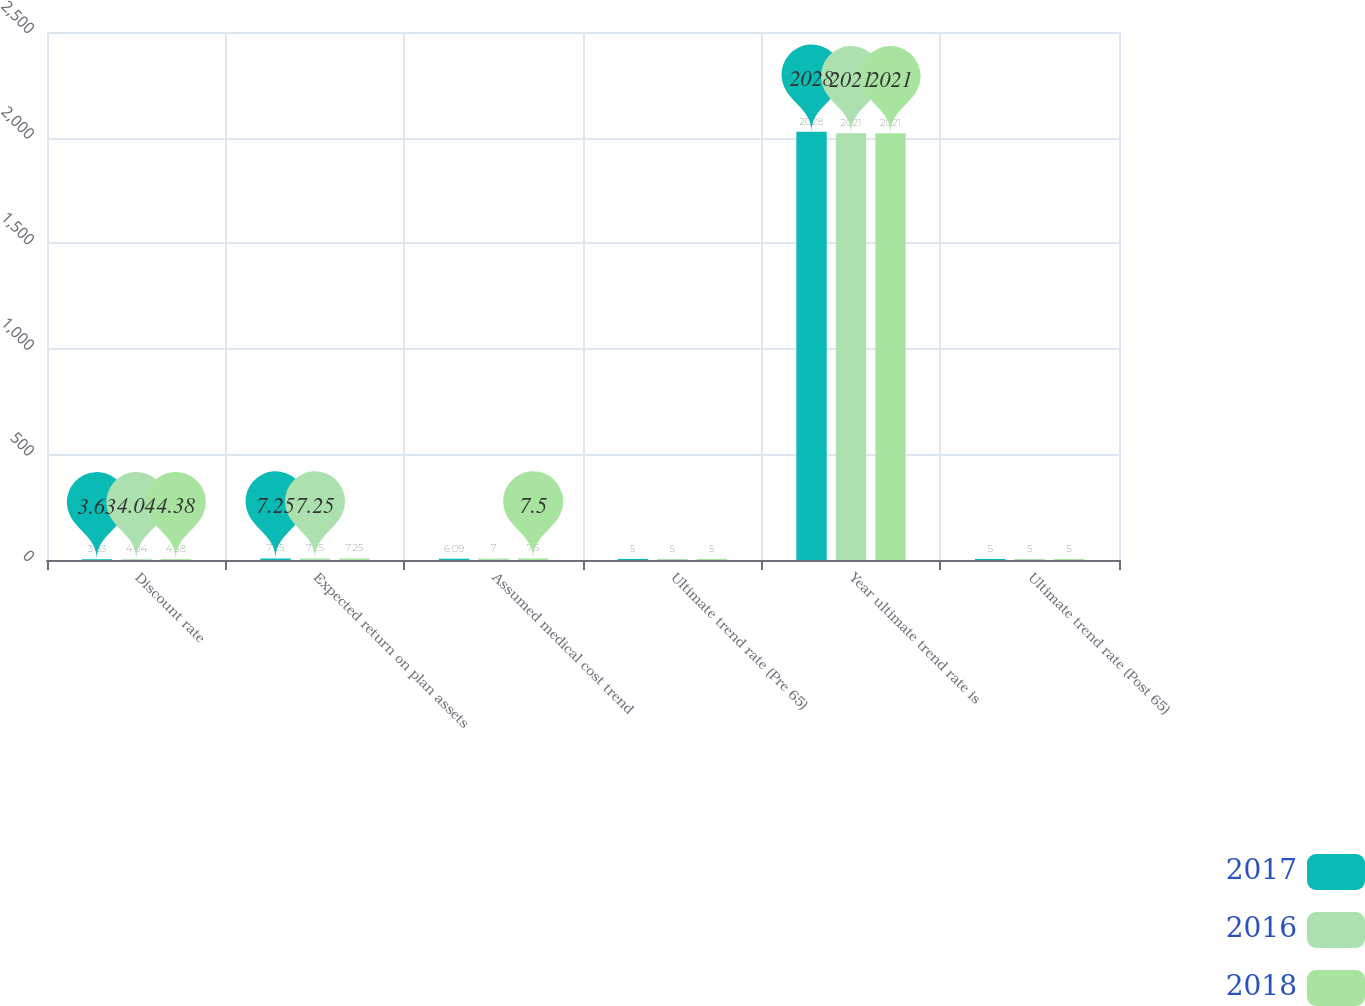Convert chart to OTSL. <chart><loc_0><loc_0><loc_500><loc_500><stacked_bar_chart><ecel><fcel>Discount rate<fcel>Expected return on plan assets<fcel>Assumed medical cost trend<fcel>Ultimate trend rate (Pre 65)<fcel>Year ultimate trend rate is<fcel>Ultimate trend rate (Post 65)<nl><fcel>2017<fcel>3.63<fcel>7.25<fcel>6.09<fcel>5<fcel>2028<fcel>5<nl><fcel>2016<fcel>4.04<fcel>7.25<fcel>7<fcel>5<fcel>2021<fcel>5<nl><fcel>2018<fcel>4.38<fcel>7.25<fcel>7.5<fcel>5<fcel>2021<fcel>5<nl></chart> 